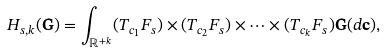Convert formula to latex. <formula><loc_0><loc_0><loc_500><loc_500>H _ { s , k } ( { \mathbf G } ) = \int _ { \mathbb { R } ^ { + k } } ( T _ { c _ { 1 } } F _ { s } ) \times ( T _ { c _ { 2 } } F _ { s } ) \times \dots \times ( T _ { c _ { k } } F _ { s } ) { \mathbf G } ( d { \mathbf c } ) ,</formula> 